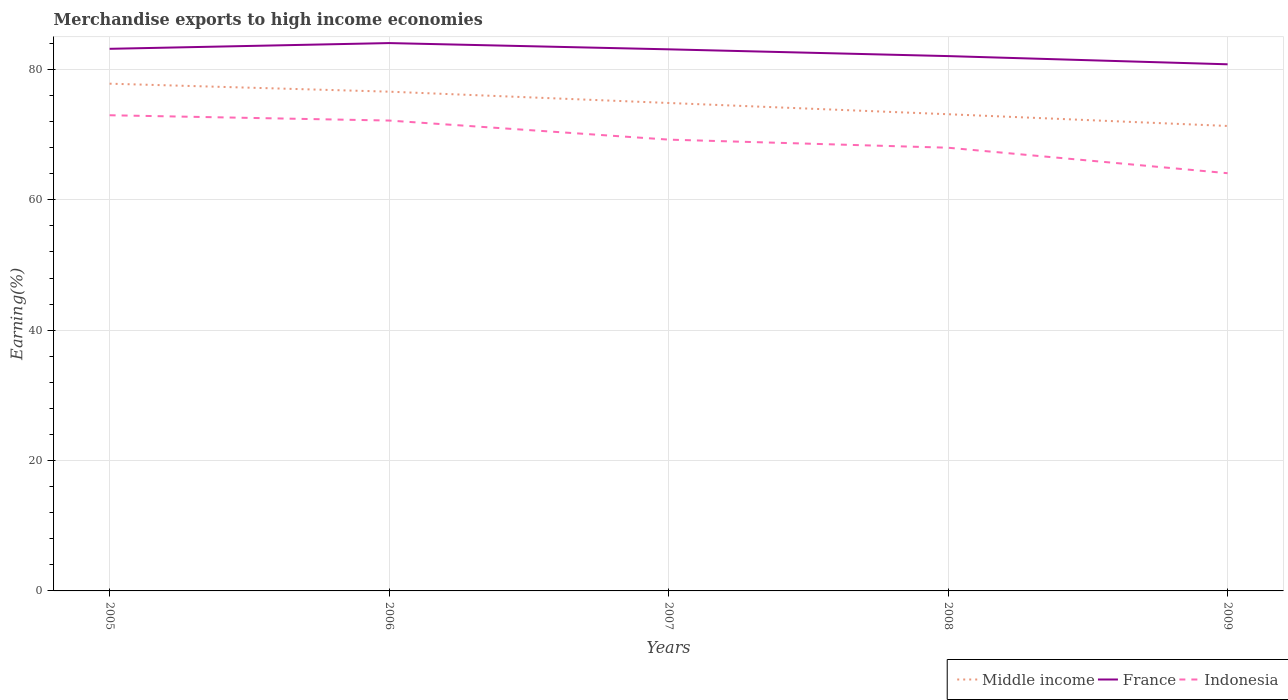How many different coloured lines are there?
Make the answer very short. 3. Across all years, what is the maximum percentage of amount earned from merchandise exports in France?
Your answer should be compact. 80.8. What is the total percentage of amount earned from merchandise exports in Indonesia in the graph?
Make the answer very short. 3.74. What is the difference between the highest and the second highest percentage of amount earned from merchandise exports in France?
Offer a terse response. 3.26. What is the difference between the highest and the lowest percentage of amount earned from merchandise exports in Indonesia?
Your answer should be very brief. 2. Is the percentage of amount earned from merchandise exports in Middle income strictly greater than the percentage of amount earned from merchandise exports in France over the years?
Your answer should be compact. Yes. How many lines are there?
Give a very brief answer. 3. How many years are there in the graph?
Offer a terse response. 5. Where does the legend appear in the graph?
Provide a short and direct response. Bottom right. How are the legend labels stacked?
Provide a short and direct response. Horizontal. What is the title of the graph?
Your answer should be very brief. Merchandise exports to high income economies. Does "Guatemala" appear as one of the legend labels in the graph?
Ensure brevity in your answer.  No. What is the label or title of the Y-axis?
Give a very brief answer. Earning(%). What is the Earning(%) of Middle income in 2005?
Your answer should be very brief. 77.82. What is the Earning(%) of France in 2005?
Your response must be concise. 83.17. What is the Earning(%) in Indonesia in 2005?
Make the answer very short. 72.98. What is the Earning(%) in Middle income in 2006?
Keep it short and to the point. 76.6. What is the Earning(%) in France in 2006?
Offer a terse response. 84.05. What is the Earning(%) in Indonesia in 2006?
Give a very brief answer. 72.17. What is the Earning(%) of Middle income in 2007?
Offer a very short reply. 74.86. What is the Earning(%) in France in 2007?
Ensure brevity in your answer.  83.09. What is the Earning(%) of Indonesia in 2007?
Offer a terse response. 69.24. What is the Earning(%) of Middle income in 2008?
Offer a terse response. 73.14. What is the Earning(%) in France in 2008?
Offer a terse response. 82.06. What is the Earning(%) in Indonesia in 2008?
Your answer should be very brief. 68. What is the Earning(%) of Middle income in 2009?
Provide a short and direct response. 71.34. What is the Earning(%) in France in 2009?
Your response must be concise. 80.8. What is the Earning(%) of Indonesia in 2009?
Your answer should be very brief. 64.09. Across all years, what is the maximum Earning(%) of Middle income?
Give a very brief answer. 77.82. Across all years, what is the maximum Earning(%) in France?
Give a very brief answer. 84.05. Across all years, what is the maximum Earning(%) in Indonesia?
Ensure brevity in your answer.  72.98. Across all years, what is the minimum Earning(%) of Middle income?
Your answer should be very brief. 71.34. Across all years, what is the minimum Earning(%) of France?
Provide a succinct answer. 80.8. Across all years, what is the minimum Earning(%) of Indonesia?
Your answer should be compact. 64.09. What is the total Earning(%) of Middle income in the graph?
Your answer should be very brief. 373.76. What is the total Earning(%) in France in the graph?
Provide a succinct answer. 413.18. What is the total Earning(%) of Indonesia in the graph?
Your answer should be compact. 346.48. What is the difference between the Earning(%) in Middle income in 2005 and that in 2006?
Provide a short and direct response. 1.23. What is the difference between the Earning(%) in France in 2005 and that in 2006?
Provide a short and direct response. -0.88. What is the difference between the Earning(%) in Indonesia in 2005 and that in 2006?
Your answer should be compact. 0.81. What is the difference between the Earning(%) of Middle income in 2005 and that in 2007?
Provide a short and direct response. 2.96. What is the difference between the Earning(%) of France in 2005 and that in 2007?
Offer a terse response. 0.08. What is the difference between the Earning(%) in Indonesia in 2005 and that in 2007?
Provide a short and direct response. 3.74. What is the difference between the Earning(%) of Middle income in 2005 and that in 2008?
Your response must be concise. 4.69. What is the difference between the Earning(%) in France in 2005 and that in 2008?
Your answer should be very brief. 1.12. What is the difference between the Earning(%) in Indonesia in 2005 and that in 2008?
Keep it short and to the point. 4.98. What is the difference between the Earning(%) in Middle income in 2005 and that in 2009?
Make the answer very short. 6.49. What is the difference between the Earning(%) of France in 2005 and that in 2009?
Offer a very short reply. 2.38. What is the difference between the Earning(%) in Indonesia in 2005 and that in 2009?
Your answer should be very brief. 8.89. What is the difference between the Earning(%) of Middle income in 2006 and that in 2007?
Your answer should be very brief. 1.74. What is the difference between the Earning(%) of France in 2006 and that in 2007?
Provide a succinct answer. 0.96. What is the difference between the Earning(%) of Indonesia in 2006 and that in 2007?
Keep it short and to the point. 2.93. What is the difference between the Earning(%) in Middle income in 2006 and that in 2008?
Your response must be concise. 3.46. What is the difference between the Earning(%) in France in 2006 and that in 2008?
Offer a terse response. 2. What is the difference between the Earning(%) of Indonesia in 2006 and that in 2008?
Offer a very short reply. 4.17. What is the difference between the Earning(%) in Middle income in 2006 and that in 2009?
Your answer should be very brief. 5.26. What is the difference between the Earning(%) in France in 2006 and that in 2009?
Provide a succinct answer. 3.26. What is the difference between the Earning(%) of Indonesia in 2006 and that in 2009?
Ensure brevity in your answer.  8.08. What is the difference between the Earning(%) of Middle income in 2007 and that in 2008?
Give a very brief answer. 1.73. What is the difference between the Earning(%) of France in 2007 and that in 2008?
Ensure brevity in your answer.  1.04. What is the difference between the Earning(%) in Indonesia in 2007 and that in 2008?
Your answer should be very brief. 1.24. What is the difference between the Earning(%) of Middle income in 2007 and that in 2009?
Offer a very short reply. 3.53. What is the difference between the Earning(%) of France in 2007 and that in 2009?
Your response must be concise. 2.3. What is the difference between the Earning(%) of Indonesia in 2007 and that in 2009?
Your answer should be very brief. 5.15. What is the difference between the Earning(%) in Middle income in 2008 and that in 2009?
Give a very brief answer. 1.8. What is the difference between the Earning(%) of France in 2008 and that in 2009?
Your answer should be very brief. 1.26. What is the difference between the Earning(%) in Indonesia in 2008 and that in 2009?
Offer a very short reply. 3.91. What is the difference between the Earning(%) of Middle income in 2005 and the Earning(%) of France in 2006?
Give a very brief answer. -6.23. What is the difference between the Earning(%) in Middle income in 2005 and the Earning(%) in Indonesia in 2006?
Offer a terse response. 5.66. What is the difference between the Earning(%) of France in 2005 and the Earning(%) of Indonesia in 2006?
Offer a terse response. 11.01. What is the difference between the Earning(%) in Middle income in 2005 and the Earning(%) in France in 2007?
Offer a terse response. -5.27. What is the difference between the Earning(%) in Middle income in 2005 and the Earning(%) in Indonesia in 2007?
Make the answer very short. 8.58. What is the difference between the Earning(%) of France in 2005 and the Earning(%) of Indonesia in 2007?
Make the answer very short. 13.93. What is the difference between the Earning(%) of Middle income in 2005 and the Earning(%) of France in 2008?
Ensure brevity in your answer.  -4.23. What is the difference between the Earning(%) in Middle income in 2005 and the Earning(%) in Indonesia in 2008?
Your answer should be compact. 9.83. What is the difference between the Earning(%) of France in 2005 and the Earning(%) of Indonesia in 2008?
Your response must be concise. 15.18. What is the difference between the Earning(%) of Middle income in 2005 and the Earning(%) of France in 2009?
Provide a succinct answer. -2.97. What is the difference between the Earning(%) in Middle income in 2005 and the Earning(%) in Indonesia in 2009?
Provide a succinct answer. 13.73. What is the difference between the Earning(%) in France in 2005 and the Earning(%) in Indonesia in 2009?
Provide a short and direct response. 19.08. What is the difference between the Earning(%) of Middle income in 2006 and the Earning(%) of France in 2007?
Provide a succinct answer. -6.5. What is the difference between the Earning(%) of Middle income in 2006 and the Earning(%) of Indonesia in 2007?
Your response must be concise. 7.36. What is the difference between the Earning(%) in France in 2006 and the Earning(%) in Indonesia in 2007?
Your answer should be very brief. 14.81. What is the difference between the Earning(%) in Middle income in 2006 and the Earning(%) in France in 2008?
Give a very brief answer. -5.46. What is the difference between the Earning(%) of Middle income in 2006 and the Earning(%) of Indonesia in 2008?
Keep it short and to the point. 8.6. What is the difference between the Earning(%) of France in 2006 and the Earning(%) of Indonesia in 2008?
Your response must be concise. 16.05. What is the difference between the Earning(%) of Middle income in 2006 and the Earning(%) of France in 2009?
Your answer should be compact. -4.2. What is the difference between the Earning(%) in Middle income in 2006 and the Earning(%) in Indonesia in 2009?
Your response must be concise. 12.51. What is the difference between the Earning(%) of France in 2006 and the Earning(%) of Indonesia in 2009?
Your answer should be very brief. 19.96. What is the difference between the Earning(%) of Middle income in 2007 and the Earning(%) of France in 2008?
Provide a succinct answer. -7.19. What is the difference between the Earning(%) in Middle income in 2007 and the Earning(%) in Indonesia in 2008?
Keep it short and to the point. 6.87. What is the difference between the Earning(%) in France in 2007 and the Earning(%) in Indonesia in 2008?
Provide a succinct answer. 15.1. What is the difference between the Earning(%) in Middle income in 2007 and the Earning(%) in France in 2009?
Give a very brief answer. -5.93. What is the difference between the Earning(%) of Middle income in 2007 and the Earning(%) of Indonesia in 2009?
Your answer should be compact. 10.77. What is the difference between the Earning(%) of France in 2007 and the Earning(%) of Indonesia in 2009?
Ensure brevity in your answer.  19. What is the difference between the Earning(%) of Middle income in 2008 and the Earning(%) of France in 2009?
Ensure brevity in your answer.  -7.66. What is the difference between the Earning(%) in Middle income in 2008 and the Earning(%) in Indonesia in 2009?
Offer a terse response. 9.05. What is the difference between the Earning(%) in France in 2008 and the Earning(%) in Indonesia in 2009?
Make the answer very short. 17.97. What is the average Earning(%) of Middle income per year?
Provide a succinct answer. 74.75. What is the average Earning(%) in France per year?
Give a very brief answer. 82.64. What is the average Earning(%) in Indonesia per year?
Keep it short and to the point. 69.3. In the year 2005, what is the difference between the Earning(%) in Middle income and Earning(%) in France?
Your answer should be compact. -5.35. In the year 2005, what is the difference between the Earning(%) of Middle income and Earning(%) of Indonesia?
Your answer should be very brief. 4.84. In the year 2005, what is the difference between the Earning(%) in France and Earning(%) in Indonesia?
Provide a succinct answer. 10.19. In the year 2006, what is the difference between the Earning(%) of Middle income and Earning(%) of France?
Make the answer very short. -7.45. In the year 2006, what is the difference between the Earning(%) of Middle income and Earning(%) of Indonesia?
Your response must be concise. 4.43. In the year 2006, what is the difference between the Earning(%) in France and Earning(%) in Indonesia?
Your response must be concise. 11.88. In the year 2007, what is the difference between the Earning(%) of Middle income and Earning(%) of France?
Keep it short and to the point. -8.23. In the year 2007, what is the difference between the Earning(%) of Middle income and Earning(%) of Indonesia?
Provide a short and direct response. 5.62. In the year 2007, what is the difference between the Earning(%) of France and Earning(%) of Indonesia?
Your answer should be very brief. 13.85. In the year 2008, what is the difference between the Earning(%) of Middle income and Earning(%) of France?
Offer a very short reply. -8.92. In the year 2008, what is the difference between the Earning(%) in Middle income and Earning(%) in Indonesia?
Ensure brevity in your answer.  5.14. In the year 2008, what is the difference between the Earning(%) in France and Earning(%) in Indonesia?
Your answer should be very brief. 14.06. In the year 2009, what is the difference between the Earning(%) in Middle income and Earning(%) in France?
Provide a short and direct response. -9.46. In the year 2009, what is the difference between the Earning(%) in Middle income and Earning(%) in Indonesia?
Your answer should be very brief. 7.25. In the year 2009, what is the difference between the Earning(%) in France and Earning(%) in Indonesia?
Your answer should be compact. 16.71. What is the ratio of the Earning(%) in Indonesia in 2005 to that in 2006?
Your answer should be compact. 1.01. What is the ratio of the Earning(%) of Middle income in 2005 to that in 2007?
Provide a short and direct response. 1.04. What is the ratio of the Earning(%) of France in 2005 to that in 2007?
Provide a succinct answer. 1. What is the ratio of the Earning(%) of Indonesia in 2005 to that in 2007?
Provide a succinct answer. 1.05. What is the ratio of the Earning(%) of Middle income in 2005 to that in 2008?
Provide a short and direct response. 1.06. What is the ratio of the Earning(%) in France in 2005 to that in 2008?
Your answer should be compact. 1.01. What is the ratio of the Earning(%) in Indonesia in 2005 to that in 2008?
Your response must be concise. 1.07. What is the ratio of the Earning(%) of France in 2005 to that in 2009?
Give a very brief answer. 1.03. What is the ratio of the Earning(%) of Indonesia in 2005 to that in 2009?
Give a very brief answer. 1.14. What is the ratio of the Earning(%) of Middle income in 2006 to that in 2007?
Offer a terse response. 1.02. What is the ratio of the Earning(%) in France in 2006 to that in 2007?
Provide a succinct answer. 1.01. What is the ratio of the Earning(%) of Indonesia in 2006 to that in 2007?
Keep it short and to the point. 1.04. What is the ratio of the Earning(%) of Middle income in 2006 to that in 2008?
Provide a short and direct response. 1.05. What is the ratio of the Earning(%) in France in 2006 to that in 2008?
Your response must be concise. 1.02. What is the ratio of the Earning(%) in Indonesia in 2006 to that in 2008?
Your answer should be compact. 1.06. What is the ratio of the Earning(%) in Middle income in 2006 to that in 2009?
Your response must be concise. 1.07. What is the ratio of the Earning(%) in France in 2006 to that in 2009?
Provide a succinct answer. 1.04. What is the ratio of the Earning(%) of Indonesia in 2006 to that in 2009?
Your response must be concise. 1.13. What is the ratio of the Earning(%) of Middle income in 2007 to that in 2008?
Provide a succinct answer. 1.02. What is the ratio of the Earning(%) of France in 2007 to that in 2008?
Your answer should be compact. 1.01. What is the ratio of the Earning(%) of Indonesia in 2007 to that in 2008?
Make the answer very short. 1.02. What is the ratio of the Earning(%) of Middle income in 2007 to that in 2009?
Your answer should be very brief. 1.05. What is the ratio of the Earning(%) of France in 2007 to that in 2009?
Provide a succinct answer. 1.03. What is the ratio of the Earning(%) in Indonesia in 2007 to that in 2009?
Your answer should be compact. 1.08. What is the ratio of the Earning(%) of Middle income in 2008 to that in 2009?
Ensure brevity in your answer.  1.03. What is the ratio of the Earning(%) of France in 2008 to that in 2009?
Ensure brevity in your answer.  1.02. What is the ratio of the Earning(%) of Indonesia in 2008 to that in 2009?
Give a very brief answer. 1.06. What is the difference between the highest and the second highest Earning(%) of Middle income?
Give a very brief answer. 1.23. What is the difference between the highest and the second highest Earning(%) in France?
Make the answer very short. 0.88. What is the difference between the highest and the second highest Earning(%) in Indonesia?
Your answer should be very brief. 0.81. What is the difference between the highest and the lowest Earning(%) in Middle income?
Provide a succinct answer. 6.49. What is the difference between the highest and the lowest Earning(%) in France?
Your answer should be very brief. 3.26. What is the difference between the highest and the lowest Earning(%) of Indonesia?
Offer a very short reply. 8.89. 